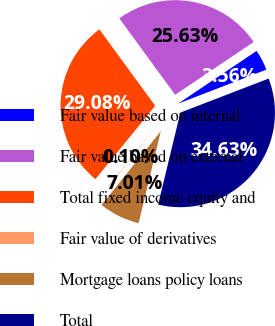Convert chart to OTSL. <chart><loc_0><loc_0><loc_500><loc_500><pie_chart><fcel>Fair value based on internal<fcel>Fair value based on external<fcel>Total fixed income equity and<fcel>Fair value of derivatives<fcel>Mortgage loans policy loans<fcel>Total<nl><fcel>3.56%<fcel>25.63%<fcel>29.08%<fcel>0.1%<fcel>7.01%<fcel>34.63%<nl></chart> 